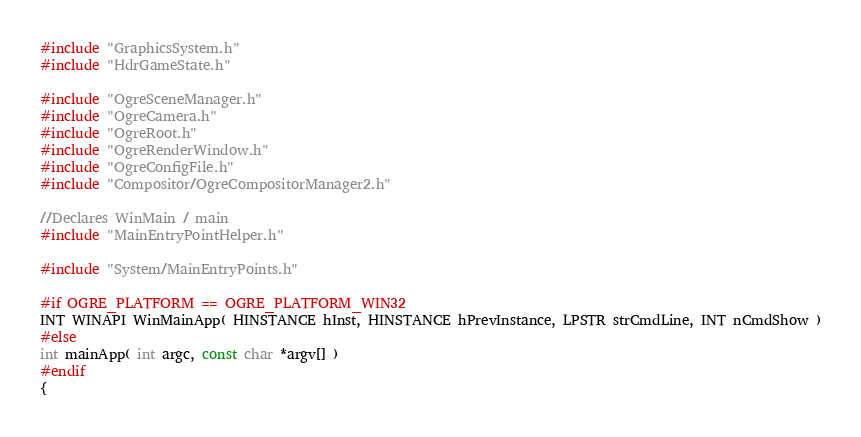Convert code to text. <code><loc_0><loc_0><loc_500><loc_500><_C++_>
#include "GraphicsSystem.h"
#include "HdrGameState.h"

#include "OgreSceneManager.h"
#include "OgreCamera.h"
#include "OgreRoot.h"
#include "OgreRenderWindow.h"
#include "OgreConfigFile.h"
#include "Compositor/OgreCompositorManager2.h"

//Declares WinMain / main
#include "MainEntryPointHelper.h"

#include "System/MainEntryPoints.h"

#if OGRE_PLATFORM == OGRE_PLATFORM_WIN32
INT WINAPI WinMainApp( HINSTANCE hInst, HINSTANCE hPrevInstance, LPSTR strCmdLine, INT nCmdShow )
#else
int mainApp( int argc, const char *argv[] )
#endif
{</code> 